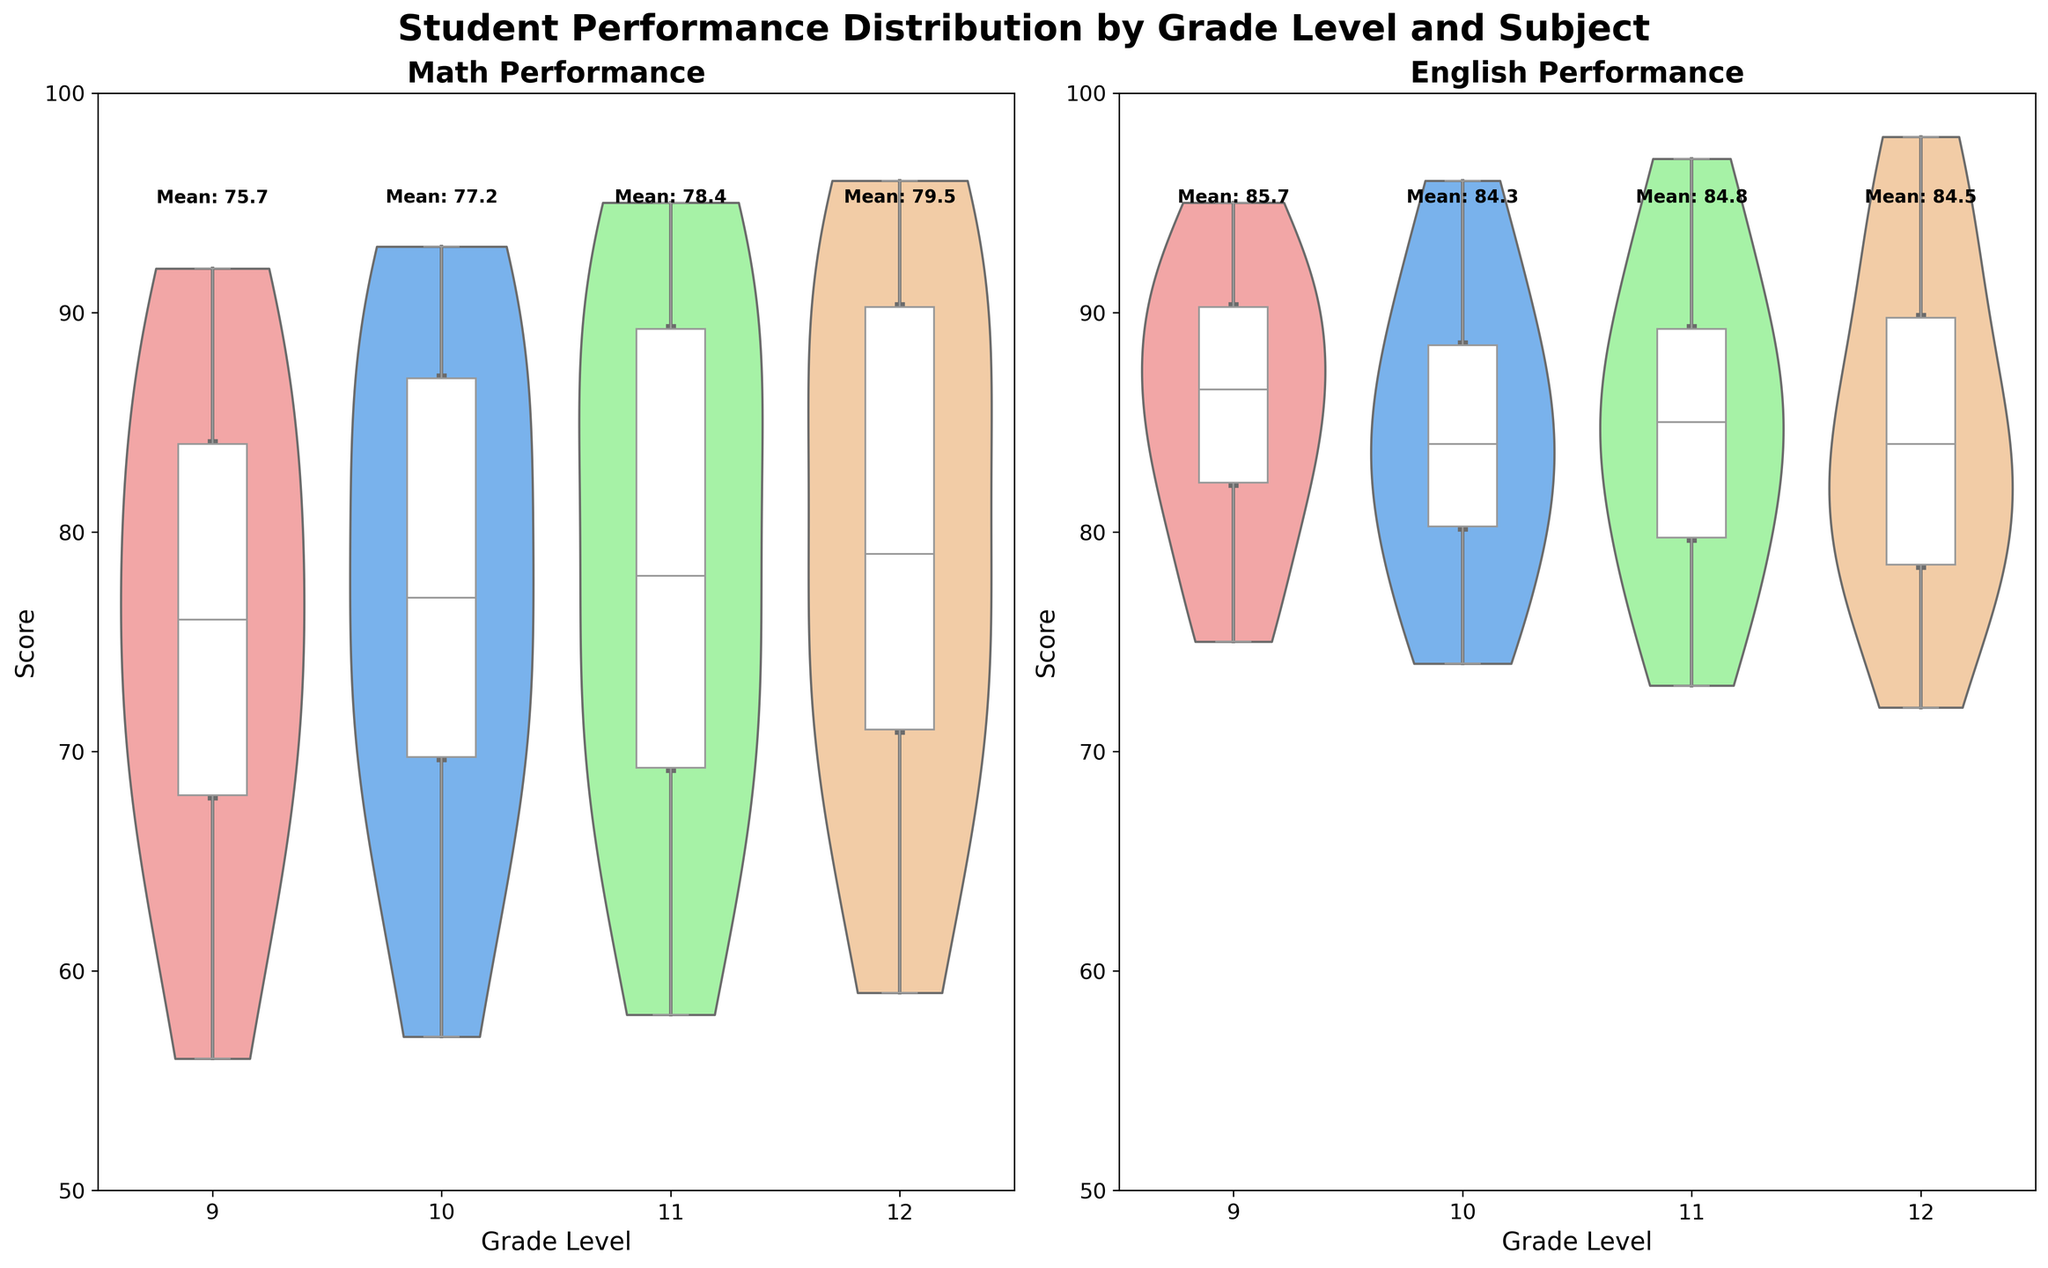What subjects are compared in the violin plots? The figure compares student performance in two subjects, Math and English. This is shown by the titles above each violin plot section.
Answer: Math and English What grade levels are included in the figure? The x-axis of each plot shows the grade levels included: 9, 10, 11, and 12.
Answer: 9, 10, 11, 12 What is the range of the y-axis for the scores? The y-axis range for the scores in both subjects spans from 50 to 100, as shown on the left side of the plots.
Answer: 50 to 100 What is the mean score for 9th grade in Math? The text above the 9th grade section in the Math violin plot shows 'Mean: 75.7'.
Answer: 75.7 How does the median score for 12th grade in English compare to 9th grade in Math? By looking at the box plot overlay within each violin, the median for 12th grade English is just above 85, while the median for 9th grade Math is closer to 74.
Answer: 12th grade English: ~85, 9th grade Math: ~74, so 12th grade English is higher What is the lowest score observed in 12th grade Math? The box plot within the 12th grade Math violin shows the lower whisker, which extends to just below 60, indicating the lowest observed score.
Answer: ~59 Which grade level in Math has the most considerable variance in scores? The width of the violin plot in Math indicates variance, where 11th grade appears the widest, suggesting the highest variance in scores.
Answer: 11th grade Do any grade levels in English show bimodal distributions? By examining the shape of the violin plots in English, none of the grade levels display two clear peaks, indicating no bimodal distributions.
Answer: No How does the interquartile range (IQR) for 10th grade English compare to 11th grade English? The IQR for 10th grade English, which is the length of the box portion in the box plot, is narrower than the IQR for 11th grade English, meaning it has a smaller spread of middle 50% scores.
Answer: 10th grade English < 11th grade English 